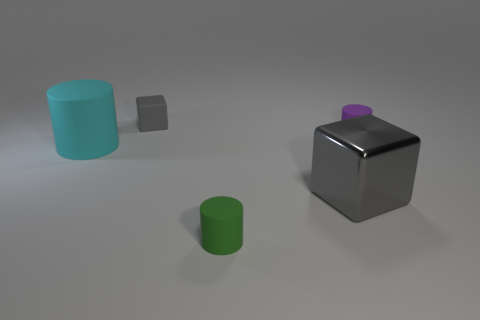Are there any purple objects?
Your answer should be very brief. Yes. There is a small thing that is the same color as the large cube; what material is it?
Offer a very short reply. Rubber. What is the size of the gray object that is on the right side of the small thing that is behind the tiny cylinder that is behind the large gray shiny block?
Provide a succinct answer. Large. There is a big rubber thing; does it have the same shape as the small thing that is on the left side of the green rubber cylinder?
Ensure brevity in your answer.  No. Is there a matte thing of the same color as the big metal thing?
Provide a succinct answer. Yes. What number of balls are small red shiny things or tiny green objects?
Provide a succinct answer. 0. Is there another tiny thing that has the same shape as the tiny gray rubber object?
Keep it short and to the point. No. How many other objects are there of the same color as the large matte object?
Offer a very short reply. 0. Are there fewer purple rubber cylinders behind the big block than rubber cylinders?
Make the answer very short. Yes. How many green metallic balls are there?
Provide a succinct answer. 0. 